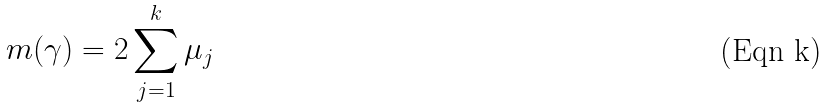Convert formula to latex. <formula><loc_0><loc_0><loc_500><loc_500>m ( \gamma ) = 2 \sum _ { j = 1 } ^ { k } \mu _ { j }</formula> 